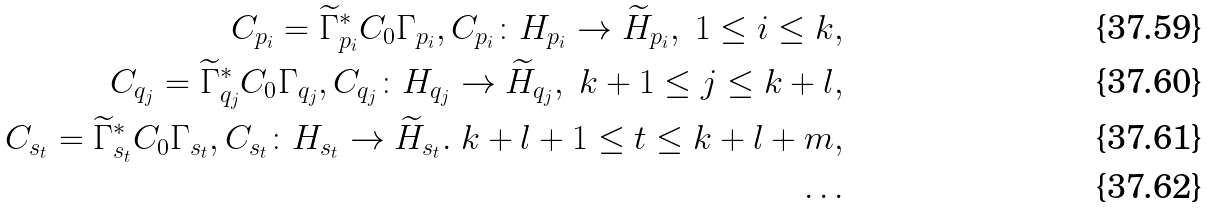Convert formula to latex. <formula><loc_0><loc_0><loc_500><loc_500>C _ { p _ { i } } = \widetilde { \Gamma } _ { p _ { i } } ^ { * } C _ { 0 } \Gamma _ { p _ { i } } , C _ { p _ { i } } \colon H _ { p _ { i } } \to \widetilde { H } _ { p _ { i } } , \ 1 \leq i \leq k , \\ C _ { q _ { j } } = \widetilde { \Gamma } _ { q _ { j } } ^ { * } C _ { 0 } \Gamma _ { q _ { j } } , C _ { q _ { j } } \colon H _ { q _ { j } } \to \widetilde { H } _ { q _ { j } } , \ k + 1 \leq j \leq k + l , \\ C _ { s _ { t } } = \widetilde { \Gamma } _ { s _ { t } } ^ { * } C _ { 0 } \Gamma _ { s _ { t } } , C _ { s _ { t } } \colon H _ { s _ { t } } \to \widetilde { H } _ { s _ { t } } . \ k + l + 1 \leq t \leq k + l + m , \\ \dots</formula> 